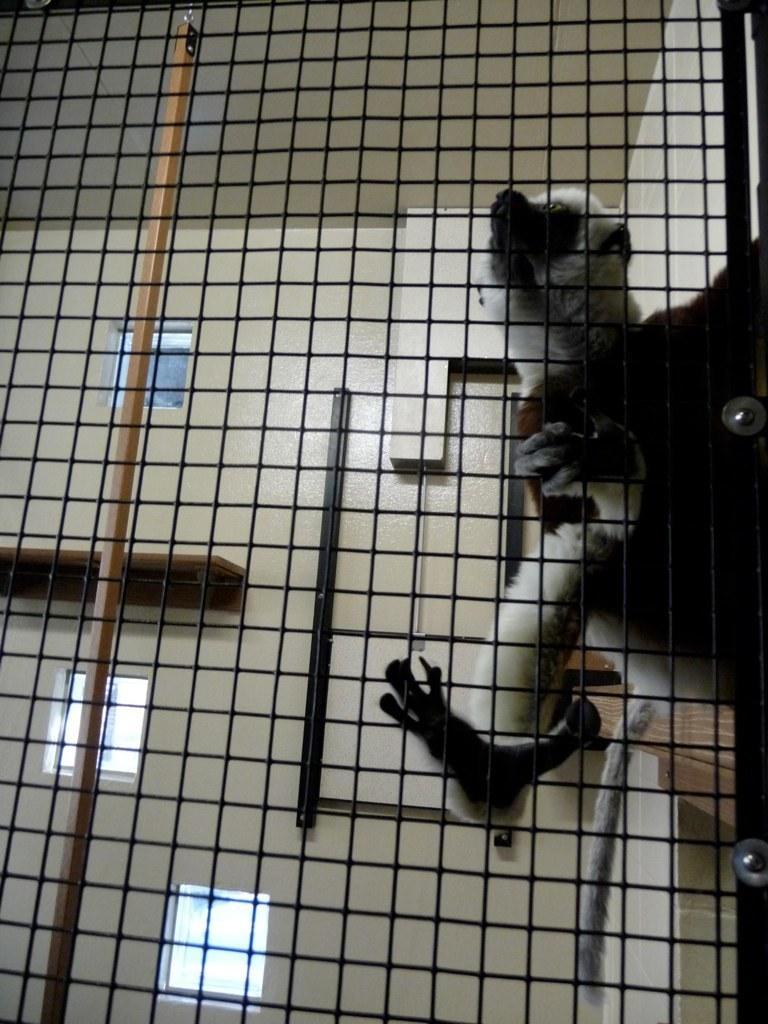In one or two sentences, can you explain what this image depicts? This is an inside view of a room. In the foreground, I can see a net. At the back of it I can see an animal is holding the net. In the background there is a war along with the windows. 